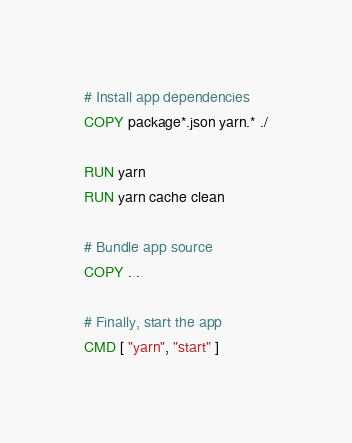<code> <loc_0><loc_0><loc_500><loc_500><_Dockerfile_># Install app dependencies
COPY package*.json yarn.* ./

RUN yarn
RUN yarn cache clean

# Bundle app source
COPY . .

# Finally, start the app
CMD [ "yarn", "start" ]</code> 